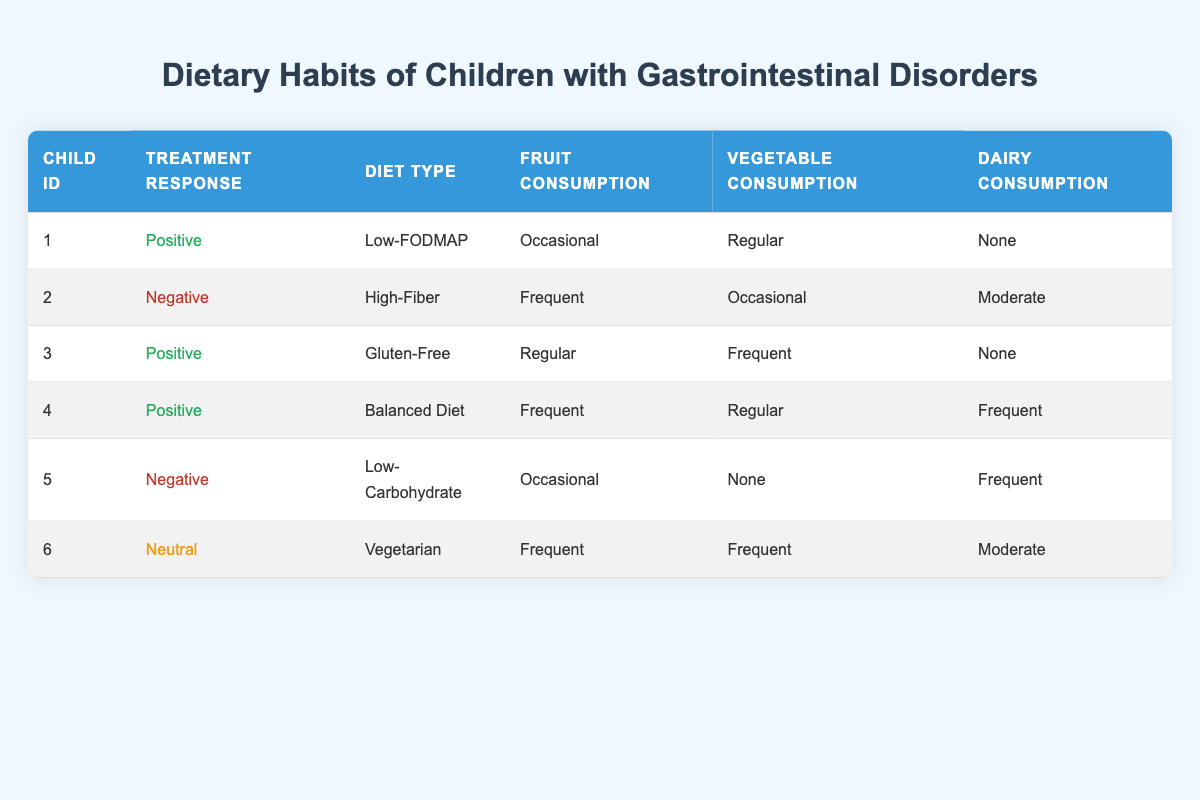What is the diet type of the child with ID 3? The table shows that child ID 3's diet type is listed in the "Diet Type" column, which states "Gluten-Free."
Answer: Gluten-Free How many children have a positive treatment response? By reviewing the "Treatment Response" column in the table, there are three instances marked as "Positive." The child IDs are 1, 3, and 4.
Answer: 3 Is there a child on a Low-Carbohydrate diet who has a positive treatment response? Checking the entries in the table, child ID 5 is on a Low-Carbohydrate diet, but their treatment response is listed as "Negative." Hence, there is no child on a Low-Carbohydrate diet with a positive response.
Answer: No What percentage of the children consume dairy frequently among those with a positive treatment response? From the three children with a positive treatment response (IDs 1, 3, and 4), only child ID 4 consumes dairy frequently. The total number of children is 3. Therefore, the percentage is (1/3) * 100 = 33.33%.
Answer: 33.33% Which diet type has the highest frequency of fruit consumption? The table reveals that child IDs 2, 4, and 6 consume fruit "Frequent," and their diet types are High-Fiber, Balanced Diet, and Vegetarian. Therefore, since there are three occurrences of "Frequent" in fruit consumption but the diet types vary, "Balanced Diet" and "Vegetarian" tie for the highest frequency as they also have frequent fruit consumption.
Answer: Balanced Diet and Vegetarian What dairy consumption level is associated with the majority of children who have a negative treatment response? A review of the relevant rows in the table shows that both children with a negative response (IDs 2 and 5) have "Moderate" and "Frequent" dairy consumption, respectively. Thus, there is no clear majority as they differ.
Answer: None (equal distribution) How many total instances of "Regular" vegetable consumption are reported among children with a positive treatment response? The children with a positive treatment response (IDs 1, 3, and 4) include two instances of "Regular" vegetable consumption: child ID 1 and child ID 4. Therefore, there are two instances of "Regular" vegetable consumption among these children.
Answer: 2 Is there a child who consumes vegetables regularly but has a negative treatment response? By checking the entries in the table, child ID 2 has "Occasional" vegetable consumption and has a negative treatment response, while child ID 5 has "None" for vegetable consumption. Hence, there is no child who meets these criteria.
Answer: No What is the ratio of children on a Low-FODMAP diet compared to those on a High-Fiber diet? According to the table, only child ID 1 is on a Low-FODMAP diet and child ID 2 is on a High-Fiber diet. Thus, the ratio is 1:1.
Answer: 1:1 